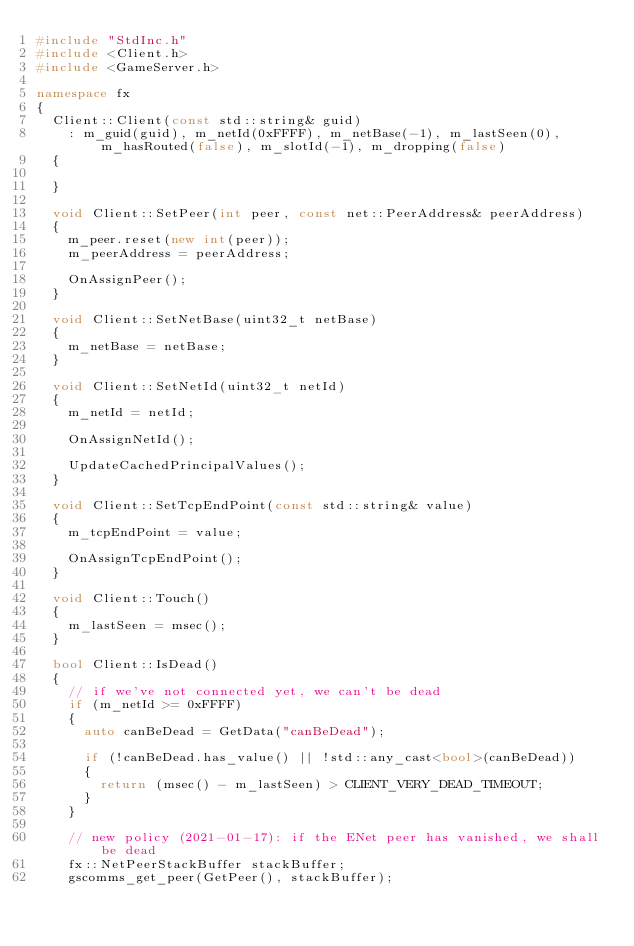<code> <loc_0><loc_0><loc_500><loc_500><_C++_>#include "StdInc.h"
#include <Client.h>
#include <GameServer.h>

namespace fx
{
	Client::Client(const std::string& guid)
		: m_guid(guid), m_netId(0xFFFF), m_netBase(-1), m_lastSeen(0), m_hasRouted(false), m_slotId(-1), m_dropping(false)
	{

	}

	void Client::SetPeer(int peer, const net::PeerAddress& peerAddress)
	{
		m_peer.reset(new int(peer));
		m_peerAddress = peerAddress;

		OnAssignPeer();
	}

	void Client::SetNetBase(uint32_t netBase)
	{
		m_netBase = netBase;
	}

	void Client::SetNetId(uint32_t netId)
	{
		m_netId = netId;

		OnAssignNetId();

		UpdateCachedPrincipalValues();
	}

	void Client::SetTcpEndPoint(const std::string& value)
	{
		m_tcpEndPoint = value;

		OnAssignTcpEndPoint();
	}

	void Client::Touch()
	{
		m_lastSeen = msec();
	}

	bool Client::IsDead()
	{
		// if we've not connected yet, we can't be dead
		if (m_netId >= 0xFFFF)
		{
			auto canBeDead = GetData("canBeDead");

			if (!canBeDead.has_value() || !std::any_cast<bool>(canBeDead))
			{
				return (msec() - m_lastSeen) > CLIENT_VERY_DEAD_TIMEOUT;
			}
		}

		// new policy (2021-01-17): if the ENet peer has vanished, we shall be dead
		fx::NetPeerStackBuffer stackBuffer;
		gscomms_get_peer(GetPeer(), stackBuffer);</code> 